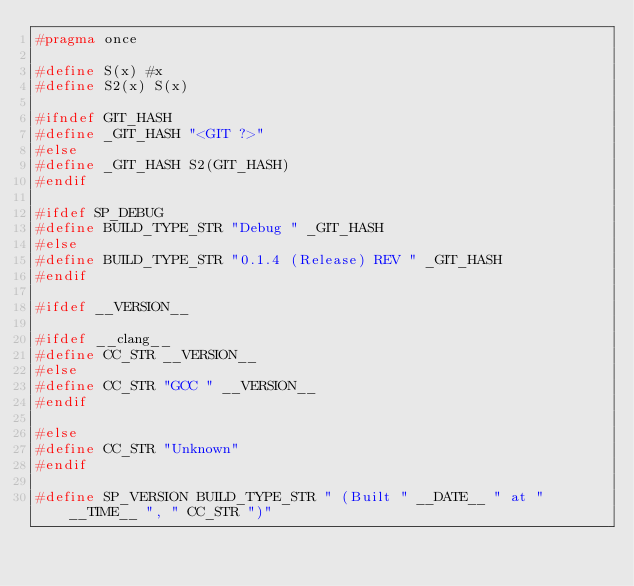Convert code to text. <code><loc_0><loc_0><loc_500><loc_500><_C_>#pragma once

#define S(x) #x
#define S2(x) S(x)

#ifndef GIT_HASH
#define _GIT_HASH "<GIT ?>"
#else
#define _GIT_HASH S2(GIT_HASH)
#endif

#ifdef SP_DEBUG
#define BUILD_TYPE_STR "Debug " _GIT_HASH
#else
#define BUILD_TYPE_STR "0.1.4 (Release) REV " _GIT_HASH
#endif

#ifdef __VERSION__

#ifdef __clang__
#define CC_STR __VERSION__
#else
#define CC_STR "GCC " __VERSION__
#endif

#else
#define CC_STR "Unknown"
#endif

#define SP_VERSION BUILD_TYPE_STR " (Built " __DATE__ " at " __TIME__ ", " CC_STR ")"
</code> 